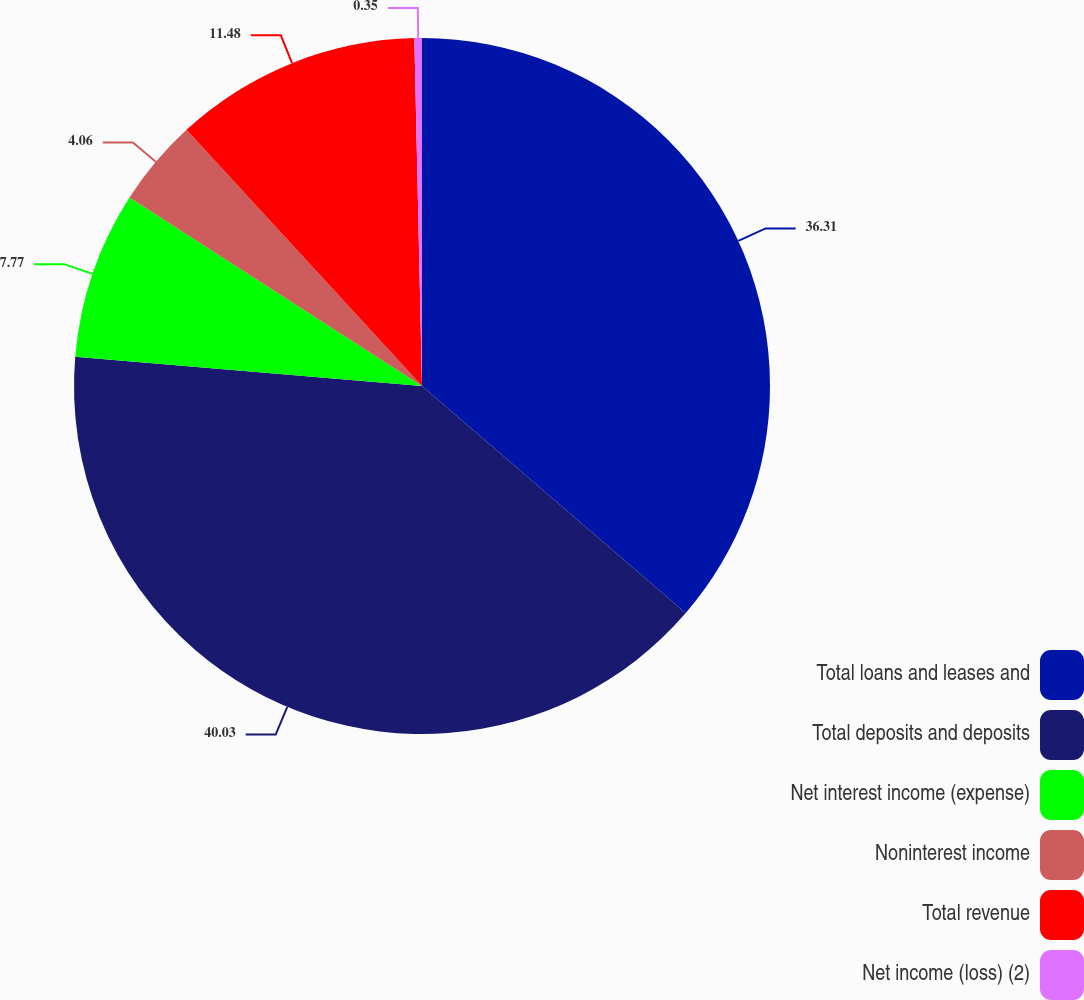Convert chart to OTSL. <chart><loc_0><loc_0><loc_500><loc_500><pie_chart><fcel>Total loans and leases and<fcel>Total deposits and deposits<fcel>Net interest income (expense)<fcel>Noninterest income<fcel>Total revenue<fcel>Net income (loss) (2)<nl><fcel>36.31%<fcel>40.02%<fcel>7.77%<fcel>4.06%<fcel>11.48%<fcel>0.35%<nl></chart> 